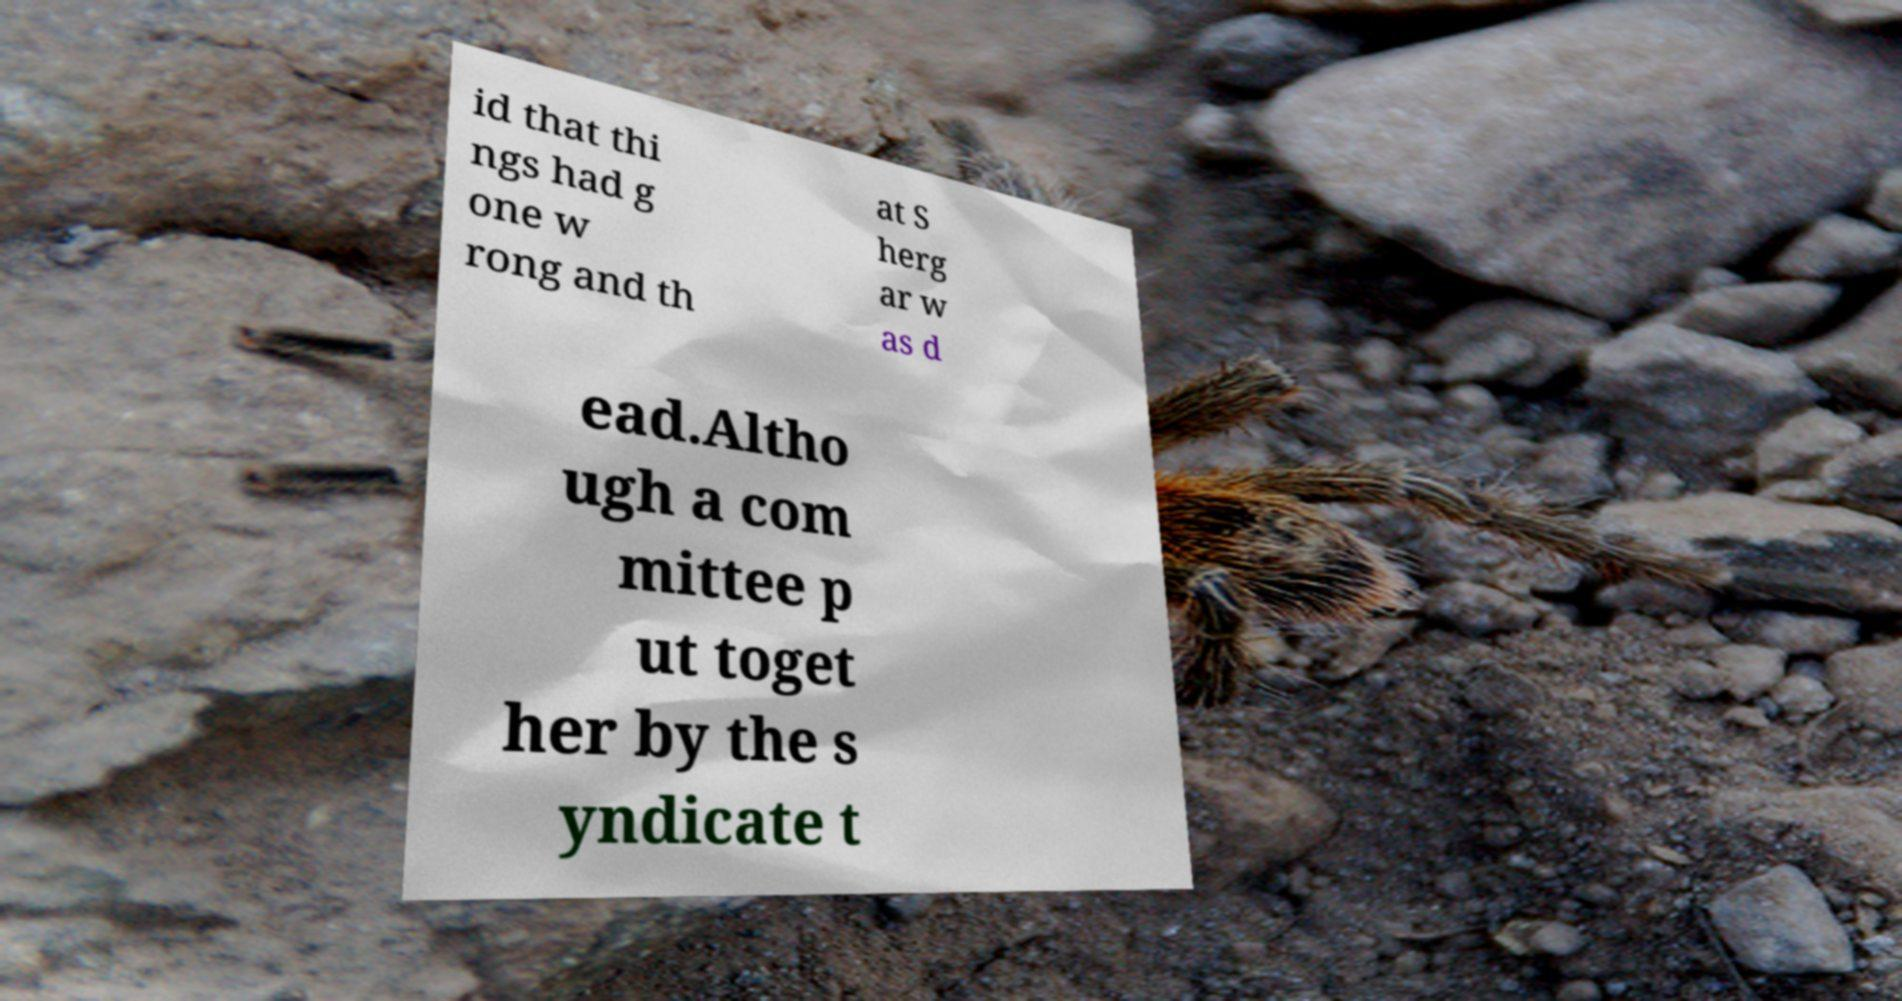Could you extract and type out the text from this image? id that thi ngs had g one w rong and th at S herg ar w as d ead.Altho ugh a com mittee p ut toget her by the s yndicate t 